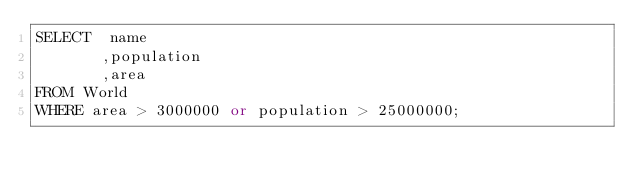Convert code to text. <code><loc_0><loc_0><loc_500><loc_500><_SQL_>SELECT  name
       ,population
       ,area
FROM World
WHERE area > 3000000 or population > 25000000; </code> 